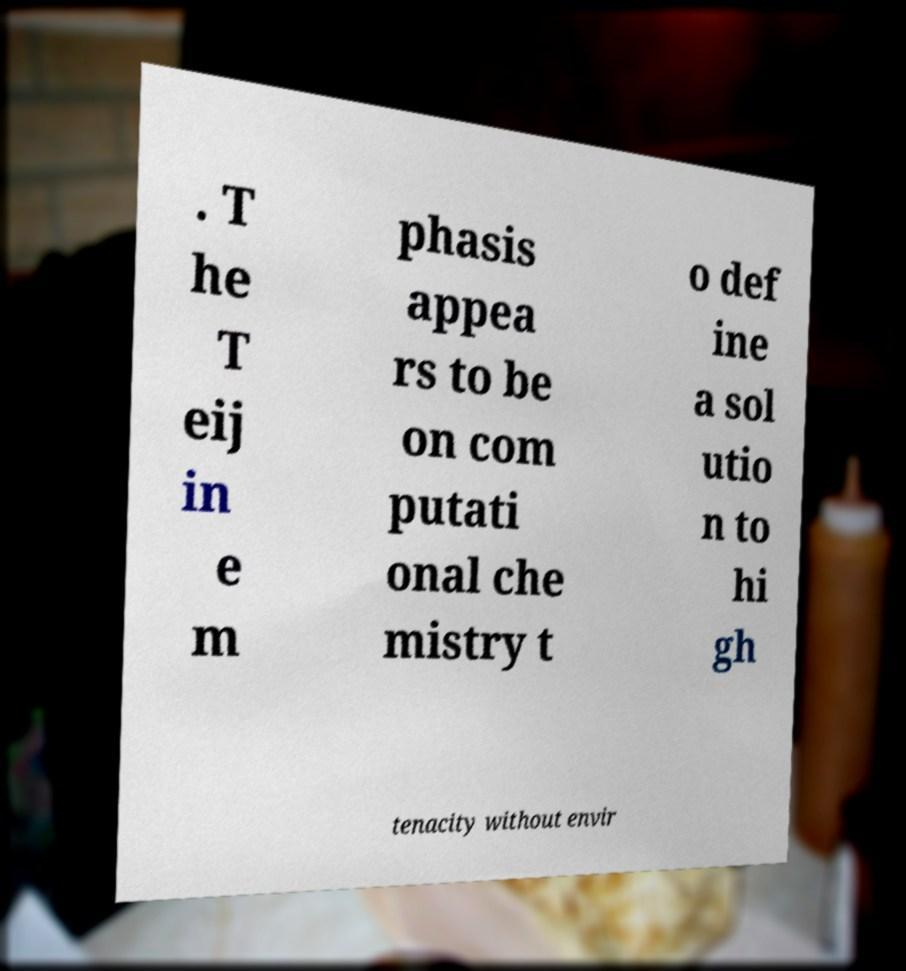There's text embedded in this image that I need extracted. Can you transcribe it verbatim? . T he T eij in e m phasis appea rs to be on com putati onal che mistry t o def ine a sol utio n to hi gh tenacity without envir 